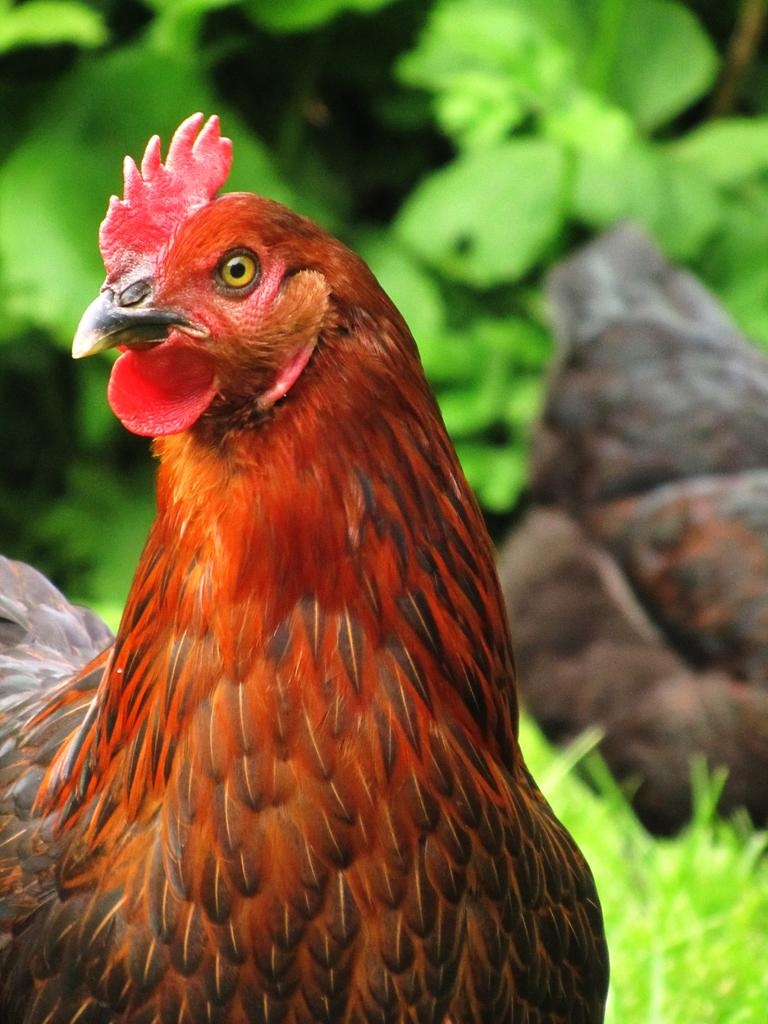What animals can be seen in the image? There are two hens in the image. Where are the hens located? The hens are on a grass path. What type of vegetation is visible in the image? There are plants visible in the image. What type of grape can be seen hanging from the plants in the image? There is no grape present in the image; only hens and plants are visible. How does the temper of the hens affect their behavior in the image? The provided facts do not mention anything about the temper of the hens, so we cannot determine how it affects their behavior in the image. 